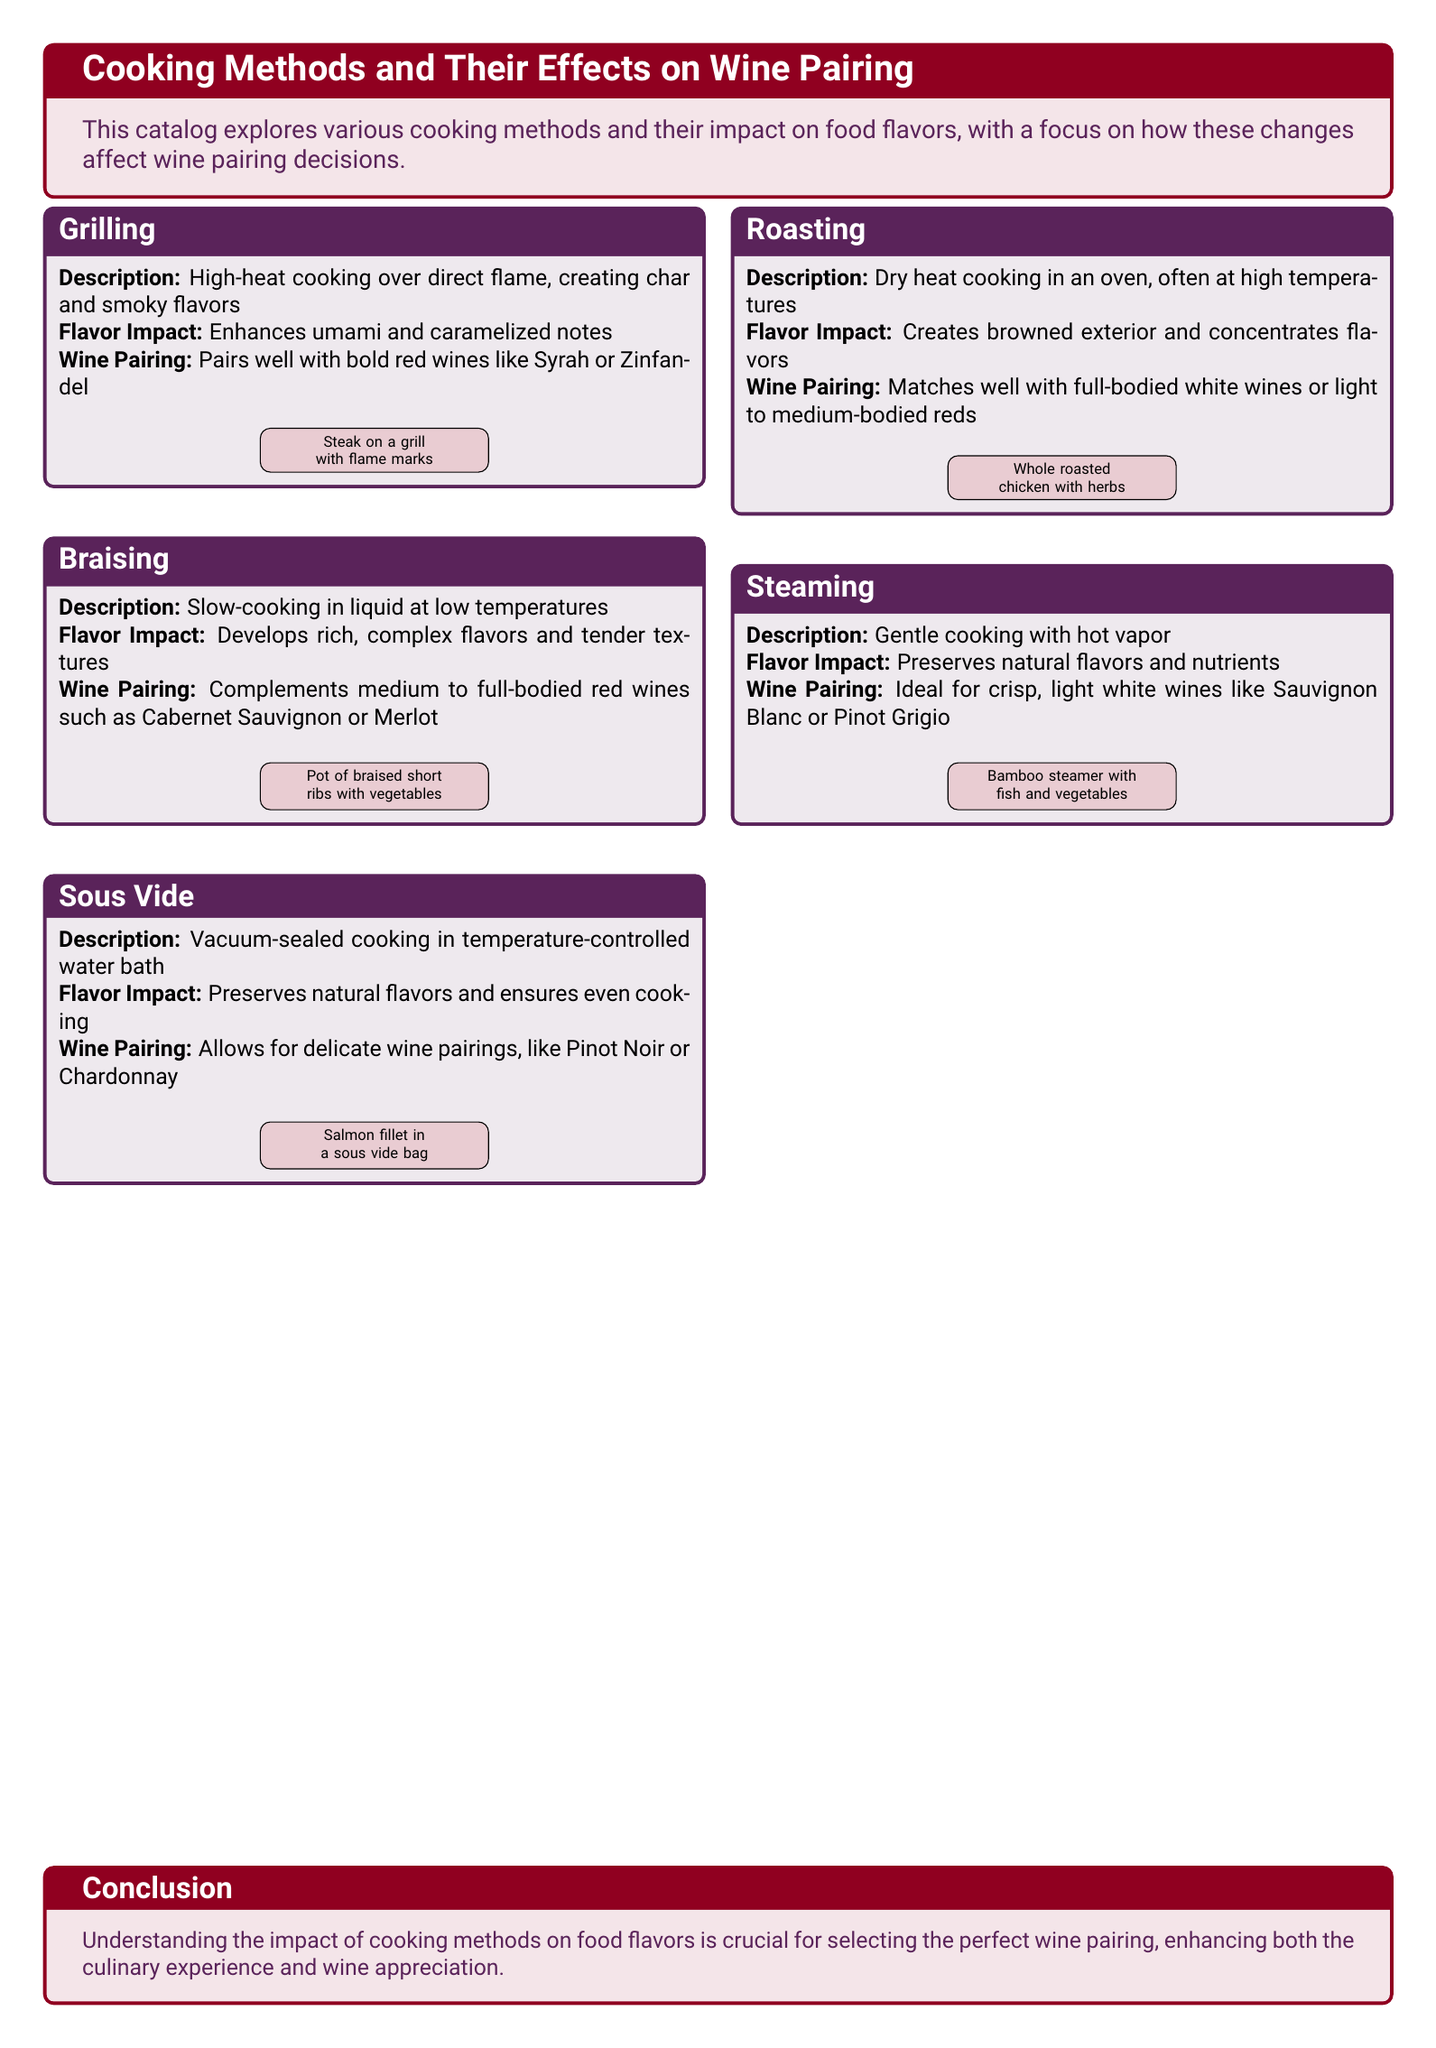What is the cooking method that enhances umami and caramelized notes? The cooking method that enhances umami and caramelized notes is grilling.
Answer: grilling Which wine pairs well with braised short ribs? Braised short ribs pair well with medium to full-bodied red wines such as Cabernet Sauvignon or Merlot.
Answer: Cabernet Sauvignon or Merlot What cooking method preserves natural flavors and ensures even cooking? The cooking method that preserves natural flavors and ensures even cooking is sous vide.
Answer: sous vide Which cooking method is ideal for crisp, light white wines? The cooking method ideal for crisp, light white wines is steaming.
Answer: steaming What type of cooking uses vacuum-sealed bags? Vacuum-sealed cooking is associated with the sous vide method.
Answer: sous vide How many cooking methods are discussed in the catalog? The catalog discusses five cooking methods in total.
Answer: five Which cooking method is related to the use of high heat? Grilling is the cooking method that is related to the use of high heat.
Answer: grilling What is the color theme used for the cooking methods section? The color theme used for the cooking methods section is purple and red.
Answer: purple and red What type of cuisine is the focus of this catalog? The focus of this catalog is on cooking methods and their impact on wine pairing.
Answer: cooking methods and their impact on wine pairing 